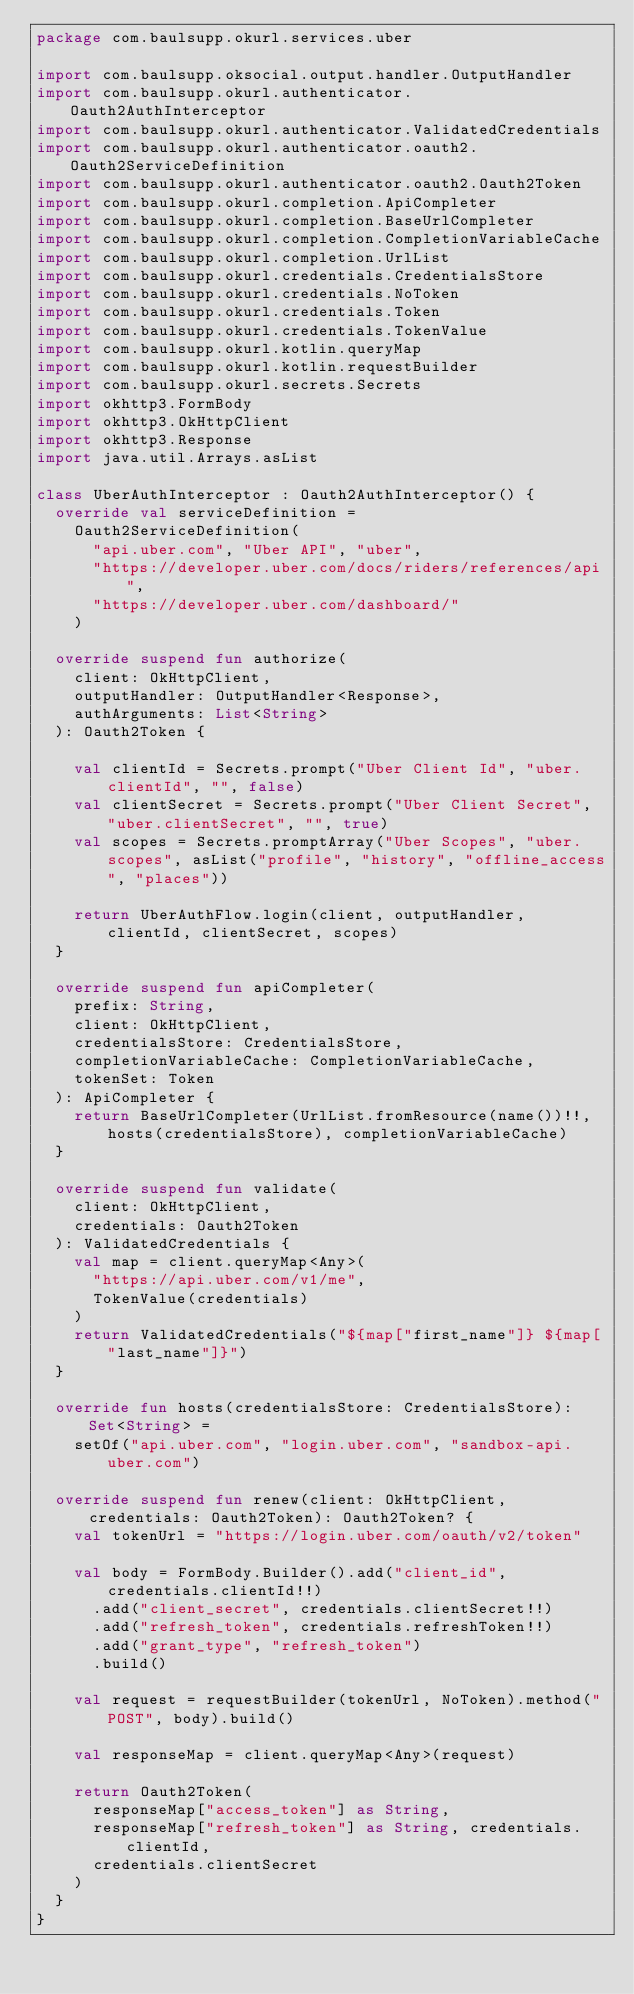Convert code to text. <code><loc_0><loc_0><loc_500><loc_500><_Kotlin_>package com.baulsupp.okurl.services.uber

import com.baulsupp.oksocial.output.handler.OutputHandler
import com.baulsupp.okurl.authenticator.Oauth2AuthInterceptor
import com.baulsupp.okurl.authenticator.ValidatedCredentials
import com.baulsupp.okurl.authenticator.oauth2.Oauth2ServiceDefinition
import com.baulsupp.okurl.authenticator.oauth2.Oauth2Token
import com.baulsupp.okurl.completion.ApiCompleter
import com.baulsupp.okurl.completion.BaseUrlCompleter
import com.baulsupp.okurl.completion.CompletionVariableCache
import com.baulsupp.okurl.completion.UrlList
import com.baulsupp.okurl.credentials.CredentialsStore
import com.baulsupp.okurl.credentials.NoToken
import com.baulsupp.okurl.credentials.Token
import com.baulsupp.okurl.credentials.TokenValue
import com.baulsupp.okurl.kotlin.queryMap
import com.baulsupp.okurl.kotlin.requestBuilder
import com.baulsupp.okurl.secrets.Secrets
import okhttp3.FormBody
import okhttp3.OkHttpClient
import okhttp3.Response
import java.util.Arrays.asList

class UberAuthInterceptor : Oauth2AuthInterceptor() {
  override val serviceDefinition =
    Oauth2ServiceDefinition(
      "api.uber.com", "Uber API", "uber",
      "https://developer.uber.com/docs/riders/references/api",
      "https://developer.uber.com/dashboard/"
    )

  override suspend fun authorize(
    client: OkHttpClient,
    outputHandler: OutputHandler<Response>,
    authArguments: List<String>
  ): Oauth2Token {

    val clientId = Secrets.prompt("Uber Client Id", "uber.clientId", "", false)
    val clientSecret = Secrets.prompt("Uber Client Secret", "uber.clientSecret", "", true)
    val scopes = Secrets.promptArray("Uber Scopes", "uber.scopes", asList("profile", "history", "offline_access", "places"))

    return UberAuthFlow.login(client, outputHandler, clientId, clientSecret, scopes)
  }

  override suspend fun apiCompleter(
    prefix: String,
    client: OkHttpClient,
    credentialsStore: CredentialsStore,
    completionVariableCache: CompletionVariableCache,
    tokenSet: Token
  ): ApiCompleter {
    return BaseUrlCompleter(UrlList.fromResource(name())!!, hosts(credentialsStore), completionVariableCache)
  }

  override suspend fun validate(
    client: OkHttpClient,
    credentials: Oauth2Token
  ): ValidatedCredentials {
    val map = client.queryMap<Any>(
      "https://api.uber.com/v1/me",
      TokenValue(credentials)
    )
    return ValidatedCredentials("${map["first_name"]} ${map["last_name"]}")
  }

  override fun hosts(credentialsStore: CredentialsStore): Set<String> =
    setOf("api.uber.com", "login.uber.com", "sandbox-api.uber.com")

  override suspend fun renew(client: OkHttpClient, credentials: Oauth2Token): Oauth2Token? {
    val tokenUrl = "https://login.uber.com/oauth/v2/token"

    val body = FormBody.Builder().add("client_id", credentials.clientId!!)
      .add("client_secret", credentials.clientSecret!!)
      .add("refresh_token", credentials.refreshToken!!)
      .add("grant_type", "refresh_token")
      .build()

    val request = requestBuilder(tokenUrl, NoToken).method("POST", body).build()

    val responseMap = client.queryMap<Any>(request)

    return Oauth2Token(
      responseMap["access_token"] as String,
      responseMap["refresh_token"] as String, credentials.clientId,
      credentials.clientSecret
    )
  }
}
</code> 